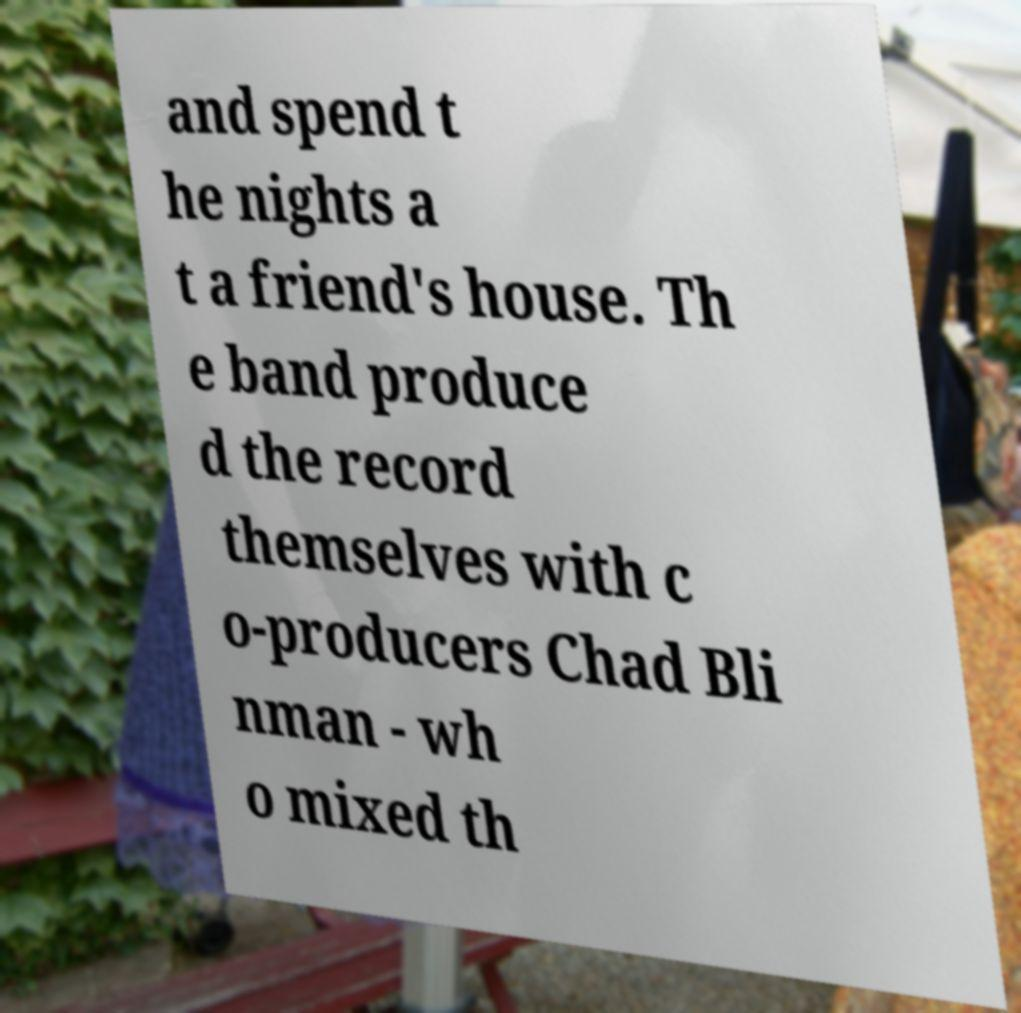Could you assist in decoding the text presented in this image and type it out clearly? and spend t he nights a t a friend's house. Th e band produce d the record themselves with c o-producers Chad Bli nman - wh o mixed th 